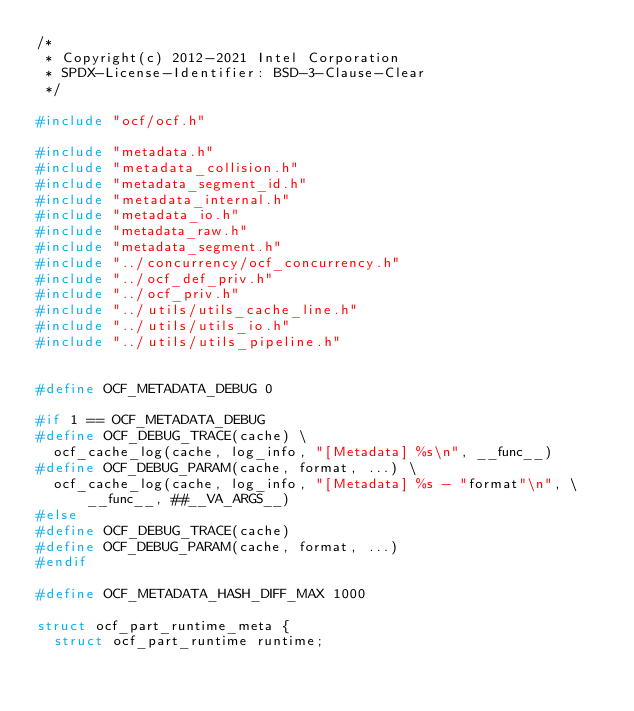<code> <loc_0><loc_0><loc_500><loc_500><_C_>/*
 * Copyright(c) 2012-2021 Intel Corporation
 * SPDX-License-Identifier: BSD-3-Clause-Clear
 */

#include "ocf/ocf.h"

#include "metadata.h"
#include "metadata_collision.h"
#include "metadata_segment_id.h"
#include "metadata_internal.h"
#include "metadata_io.h"
#include "metadata_raw.h"
#include "metadata_segment.h"
#include "../concurrency/ocf_concurrency.h"
#include "../ocf_def_priv.h"
#include "../ocf_priv.h"
#include "../utils/utils_cache_line.h"
#include "../utils/utils_io.h"
#include "../utils/utils_pipeline.h"


#define OCF_METADATA_DEBUG 0

#if 1 == OCF_METADATA_DEBUG
#define OCF_DEBUG_TRACE(cache) \
	ocf_cache_log(cache, log_info, "[Metadata] %s\n", __func__)
#define OCF_DEBUG_PARAM(cache, format, ...) \
	ocf_cache_log(cache, log_info, "[Metadata] %s - "format"\n", \
			__func__, ##__VA_ARGS__)
#else
#define OCF_DEBUG_TRACE(cache)
#define OCF_DEBUG_PARAM(cache, format, ...)
#endif

#define OCF_METADATA_HASH_DIFF_MAX 1000

struct ocf_part_runtime_meta {
	struct ocf_part_runtime runtime;</code> 